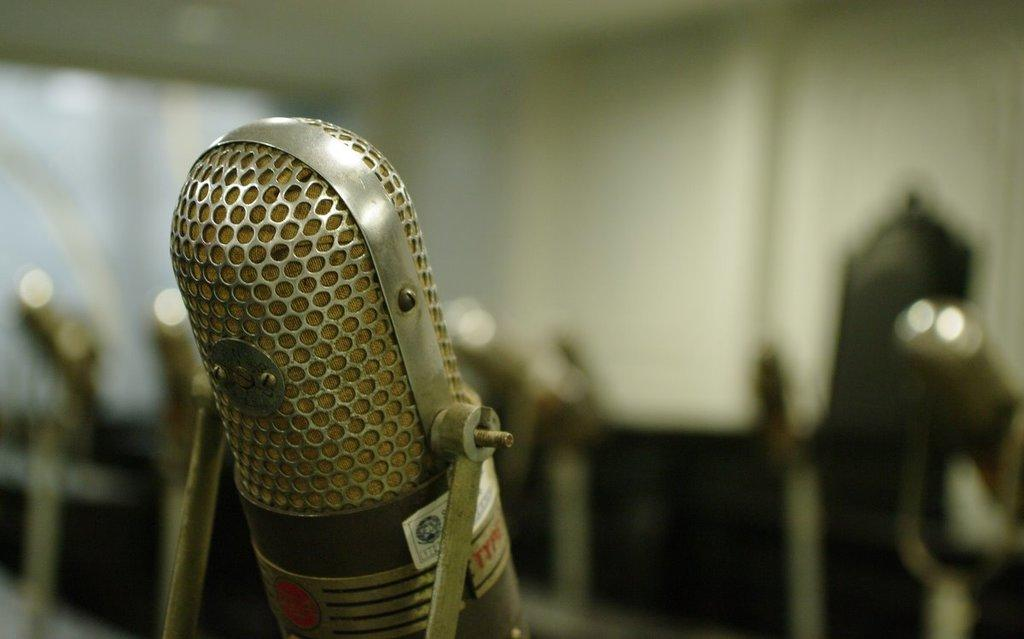What is the main object in the image? There is a microphone in the image. Can you tell me how many maids are standing next to the microphone in the image? There is no mention of a maid or any person in the image; it only features a microphone. 